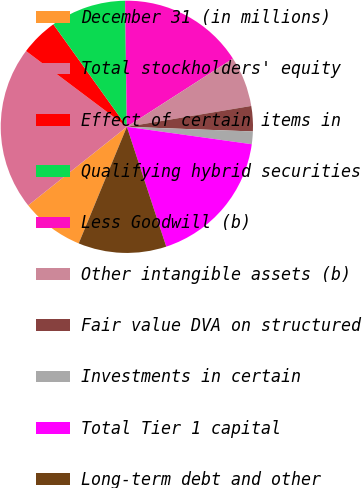<chart> <loc_0><loc_0><loc_500><loc_500><pie_chart><fcel>December 31 (in millions)<fcel>Total stockholders' equity<fcel>Effect of certain items in<fcel>Qualifying hybrid securities<fcel>Less Goodwill (b)<fcel>Other intangible assets (b)<fcel>Fair value DVA on structured<fcel>Investments in certain<fcel>Total Tier 1 capital<fcel>Long-term debt and other<nl><fcel>8.07%<fcel>20.96%<fcel>4.84%<fcel>9.68%<fcel>16.13%<fcel>6.45%<fcel>3.23%<fcel>1.62%<fcel>17.74%<fcel>11.29%<nl></chart> 